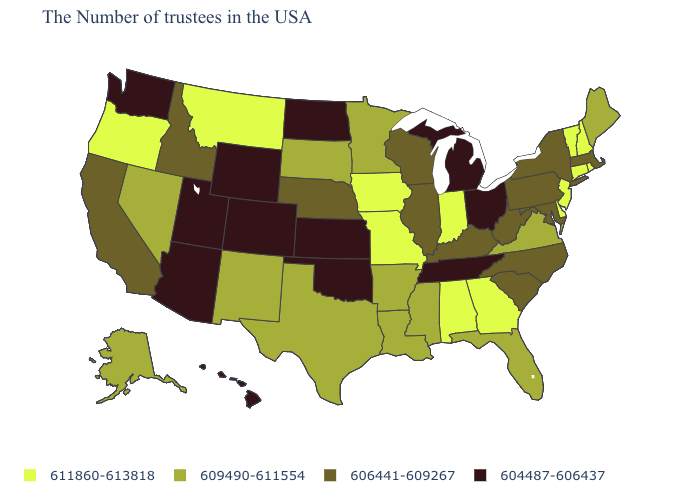Name the states that have a value in the range 611860-613818?
Keep it brief. Rhode Island, New Hampshire, Vermont, Connecticut, New Jersey, Delaware, Georgia, Indiana, Alabama, Missouri, Iowa, Montana, Oregon. What is the value of Georgia?
Be succinct. 611860-613818. What is the value of Montana?
Concise answer only. 611860-613818. Among the states that border Maryland , which have the highest value?
Short answer required. Delaware. How many symbols are there in the legend?
Concise answer only. 4. Name the states that have a value in the range 609490-611554?
Quick response, please. Maine, Virginia, Florida, Mississippi, Louisiana, Arkansas, Minnesota, Texas, South Dakota, New Mexico, Nevada, Alaska. Name the states that have a value in the range 611860-613818?
Answer briefly. Rhode Island, New Hampshire, Vermont, Connecticut, New Jersey, Delaware, Georgia, Indiana, Alabama, Missouri, Iowa, Montana, Oregon. What is the highest value in the USA?
Give a very brief answer. 611860-613818. Does Wyoming have the same value as North Dakota?
Be succinct. Yes. Among the states that border Louisiana , which have the lowest value?
Keep it brief. Mississippi, Arkansas, Texas. How many symbols are there in the legend?
Give a very brief answer. 4. What is the highest value in states that border Maine?
Short answer required. 611860-613818. Which states hav the highest value in the MidWest?
Keep it brief. Indiana, Missouri, Iowa. Name the states that have a value in the range 611860-613818?
Quick response, please. Rhode Island, New Hampshire, Vermont, Connecticut, New Jersey, Delaware, Georgia, Indiana, Alabama, Missouri, Iowa, Montana, Oregon. 